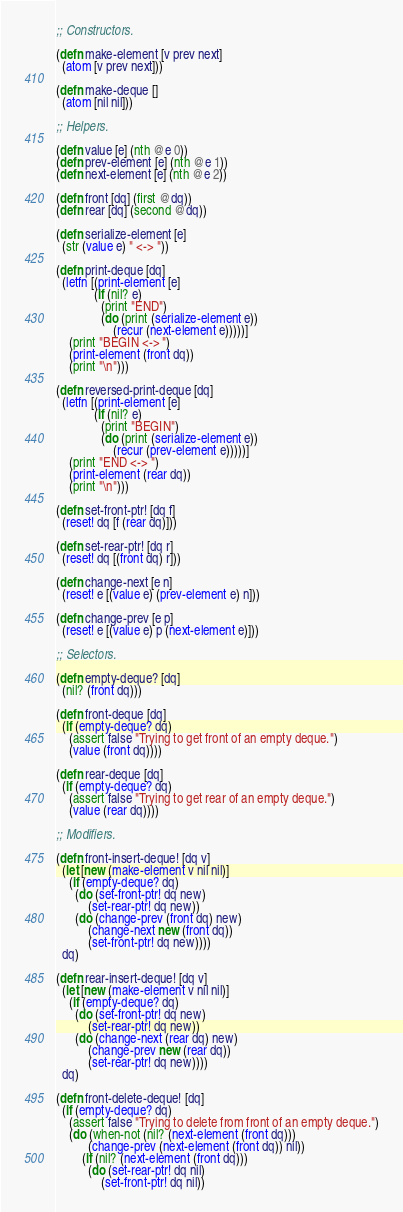<code> <loc_0><loc_0><loc_500><loc_500><_Clojure_>;; Constructors.

(defn make-element [v prev next]
  (atom [v prev next]))

(defn make-deque []
  (atom [nil nil]))

;; Helpers.

(defn value [e] (nth @e 0))
(defn prev-element [e] (nth @e 1))
(defn next-element [e] (nth @e 2))

(defn front [dq] (first @dq))
(defn rear [dq] (second @dq))

(defn serialize-element [e]
  (str (value e) " <-> "))

(defn print-deque [dq]
  (letfn [(print-element [e]
            (if (nil? e)
              (print "END")
              (do (print (serialize-element e))
                  (recur (next-element e)))))]
    (print "BEGIN <-> ")
    (print-element (front dq))
    (print "\n")))

(defn reversed-print-deque [dq]
  (letfn [(print-element [e]
            (if (nil? e)
              (print "BEGIN")
              (do (print (serialize-element e))
                  (recur (prev-element e)))))]
    (print "END <-> ")
    (print-element (rear dq))
    (print "\n")))

(defn set-front-ptr! [dq f]
  (reset! dq [f (rear dq)]))

(defn set-rear-ptr! [dq r]
  (reset! dq [(front dq) r]))

(defn change-next [e n]
  (reset! e [(value e) (prev-element e) n]))

(defn change-prev [e p]
  (reset! e [(value e) p (next-element e)]))

;; Selectors.

(defn empty-deque? [dq]
  (nil? (front dq)))

(defn front-deque [dq]
  (if (empty-deque? dq)
    (assert false "Trying to get front of an empty deque.")
    (value (front dq))))

(defn rear-deque [dq]
  (if (empty-deque? dq)
    (assert false "Trying to get rear of an empty deque.")
    (value (rear dq))))

;; Modifiers.

(defn front-insert-deque! [dq v]
  (let [new (make-element v nil nil)]
    (if (empty-deque? dq)
      (do (set-front-ptr! dq new)
          (set-rear-ptr! dq new))
      (do (change-prev (front dq) new)
          (change-next new (front dq))
          (set-front-ptr! dq new))))
  dq)

(defn rear-insert-deque! [dq v]
  (let [new (make-element v nil nil)]
    (if (empty-deque? dq)
      (do (set-front-ptr! dq new)
          (set-rear-ptr! dq new))
      (do (change-next (rear dq) new)
          (change-prev new (rear dq))
          (set-rear-ptr! dq new))))
  dq)

(defn front-delete-deque! [dq]
  (if (empty-deque? dq)
    (assert false "Trying to delete from front of an empty deque.")
    (do (when-not (nil? (next-element (front dq)))
          (change-prev (next-element (front dq)) nil))
        (if (nil? (next-element (front dq)))
          (do (set-rear-ptr! dq nil)
              (set-front-ptr! dq nil))</code> 